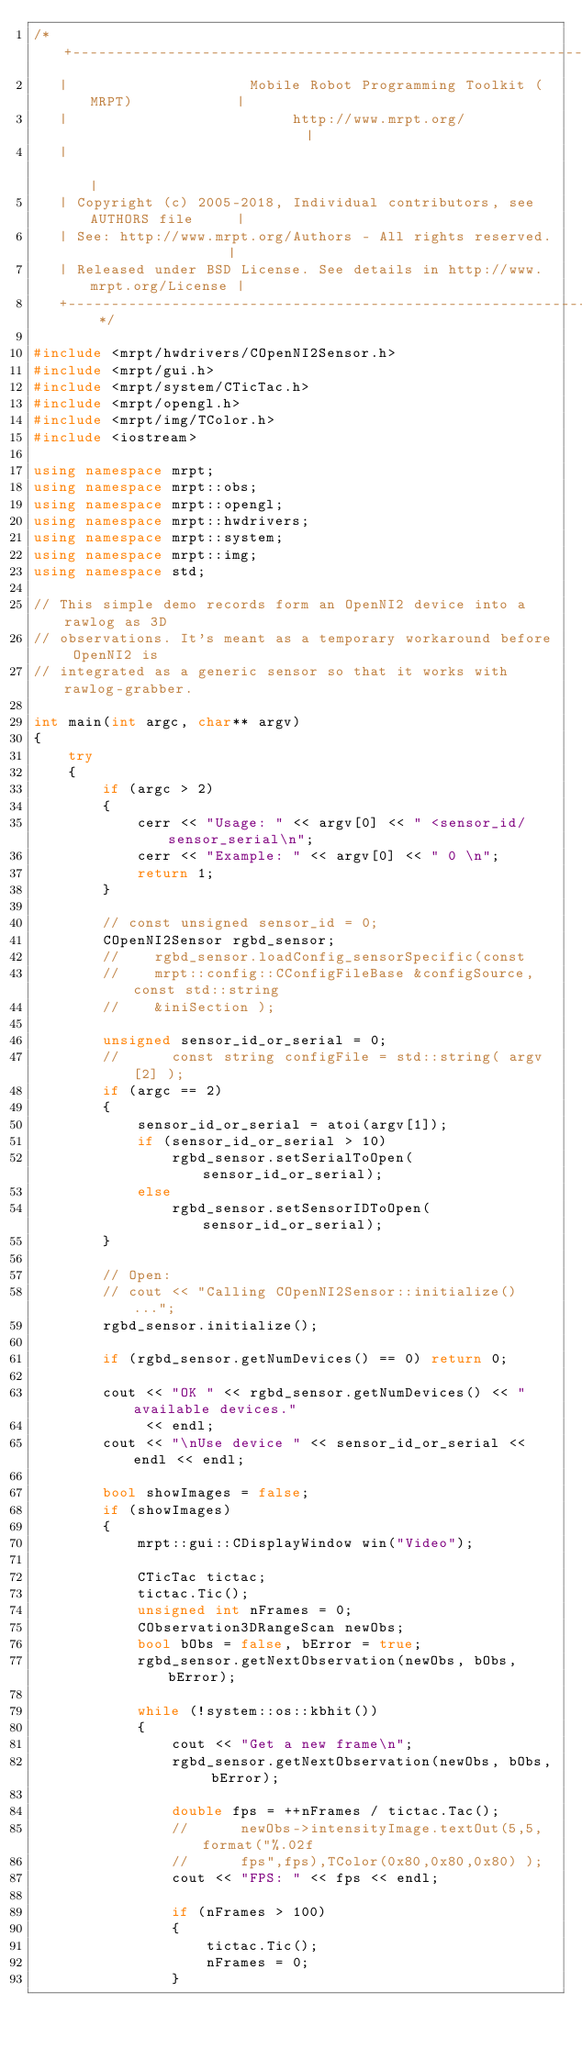<code> <loc_0><loc_0><loc_500><loc_500><_C++_>/* +------------------------------------------------------------------------+
   |                     Mobile Robot Programming Toolkit (MRPT)            |
   |                          http://www.mrpt.org/                          |
   |                                                                        |
   | Copyright (c) 2005-2018, Individual contributors, see AUTHORS file     |
   | See: http://www.mrpt.org/Authors - All rights reserved.                |
   | Released under BSD License. See details in http://www.mrpt.org/License |
   +------------------------------------------------------------------------+ */

#include <mrpt/hwdrivers/COpenNI2Sensor.h>
#include <mrpt/gui.h>
#include <mrpt/system/CTicTac.h>
#include <mrpt/opengl.h>
#include <mrpt/img/TColor.h>
#include <iostream>

using namespace mrpt;
using namespace mrpt::obs;
using namespace mrpt::opengl;
using namespace mrpt::hwdrivers;
using namespace mrpt::system;
using namespace mrpt::img;
using namespace std;

// This simple demo records form an OpenNI2 device into a rawlog as 3D
// observations. It's meant as a temporary workaround before OpenNI2 is
// integrated as a generic sensor so that it works with rawlog-grabber.

int main(int argc, char** argv)
{
	try
	{
		if (argc > 2)
		{
			cerr << "Usage: " << argv[0] << " <sensor_id/sensor_serial\n";
			cerr << "Example: " << argv[0] << " 0 \n";
			return 1;
		}

		// const unsigned sensor_id = 0;
		COpenNI2Sensor rgbd_sensor;
		//    rgbd_sensor.loadConfig_sensorSpecific(const
		//    mrpt::config::CConfigFileBase &configSource,	const std::string
		//    &iniSection );

		unsigned sensor_id_or_serial = 0;
		//		const string configFile = std::string( argv[2] );
		if (argc == 2)
		{
			sensor_id_or_serial = atoi(argv[1]);
			if (sensor_id_or_serial > 10)
				rgbd_sensor.setSerialToOpen(sensor_id_or_serial);
			else
				rgbd_sensor.setSensorIDToOpen(sensor_id_or_serial);
		}

		// Open:
		// cout << "Calling COpenNI2Sensor::initialize()...";
		rgbd_sensor.initialize();

		if (rgbd_sensor.getNumDevices() == 0) return 0;

		cout << "OK " << rgbd_sensor.getNumDevices() << " available devices."
			 << endl;
		cout << "\nUse device " << sensor_id_or_serial << endl << endl;

		bool showImages = false;
		if (showImages)
		{
			mrpt::gui::CDisplayWindow win("Video");

			CTicTac tictac;
			tictac.Tic();
			unsigned int nFrames = 0;
			CObservation3DRangeScan newObs;
			bool bObs = false, bError = true;
			rgbd_sensor.getNextObservation(newObs, bObs, bError);

			while (!system::os::kbhit())
			{
				cout << "Get a new frame\n";
				rgbd_sensor.getNextObservation(newObs, bObs, bError);

				double fps = ++nFrames / tictac.Tac();
				//      newObs->intensityImage.textOut(5,5,format("%.02f
				//      fps",fps),TColor(0x80,0x80,0x80) );
				cout << "FPS: " << fps << endl;

				if (nFrames > 100)
				{
					tictac.Tic();
					nFrames = 0;
				}
</code> 